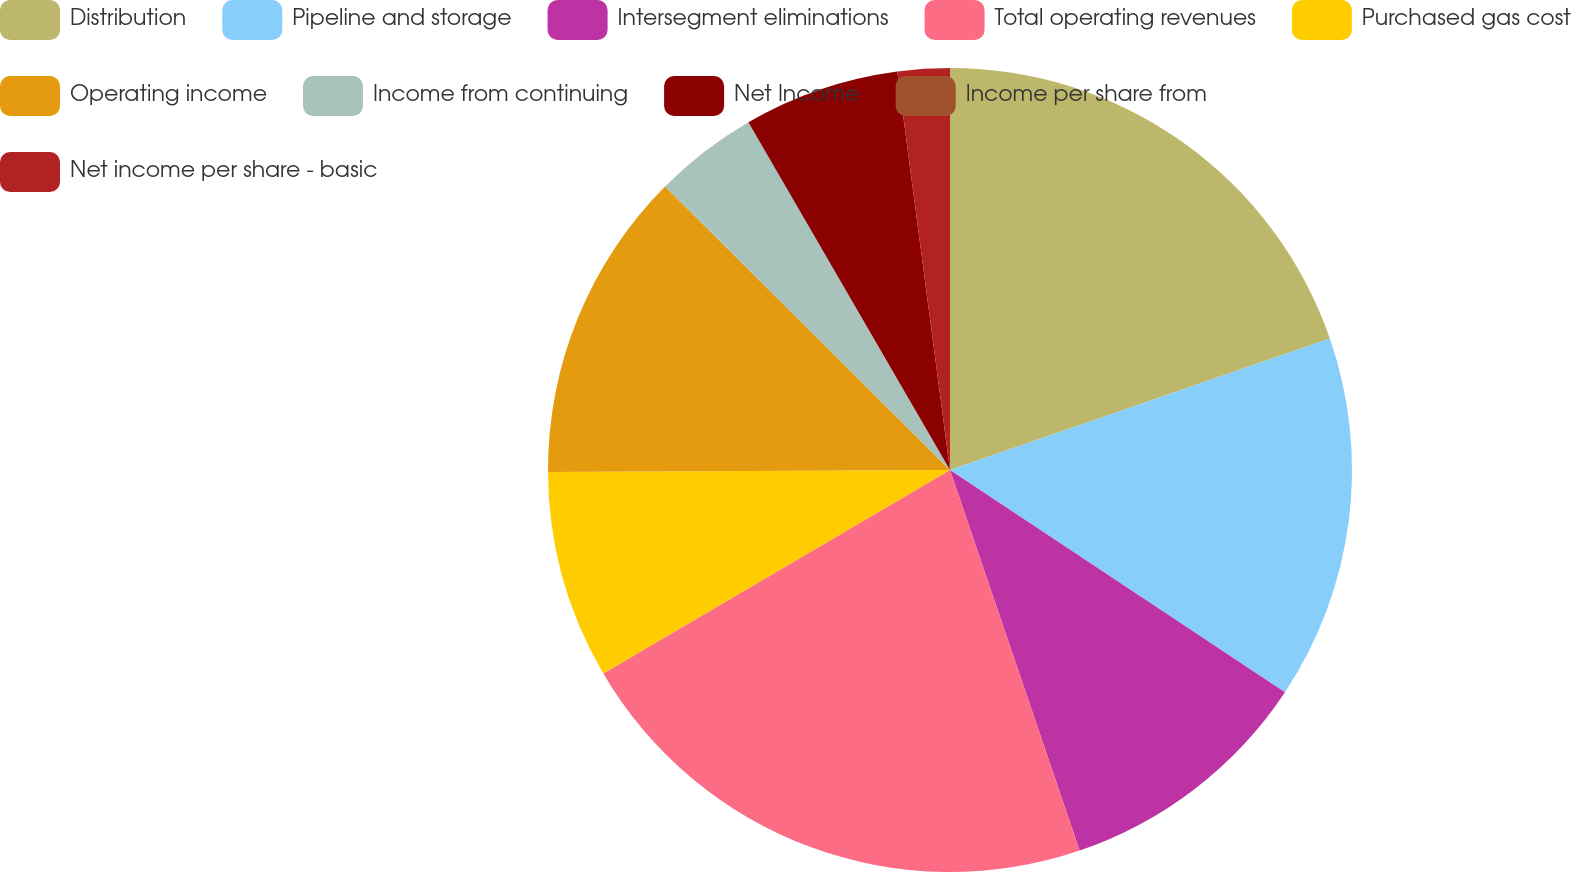Convert chart. <chart><loc_0><loc_0><loc_500><loc_500><pie_chart><fcel>Distribution<fcel>Pipeline and storage<fcel>Intersegment eliminations<fcel>Total operating revenues<fcel>Purchased gas cost<fcel>Operating income<fcel>Income from continuing<fcel>Net Income<fcel>Income per share from<fcel>Net income per share - basic<nl><fcel>19.69%<fcel>14.63%<fcel>10.45%<fcel>21.78%<fcel>8.36%<fcel>12.54%<fcel>4.18%<fcel>6.27%<fcel>0.0%<fcel>2.09%<nl></chart> 